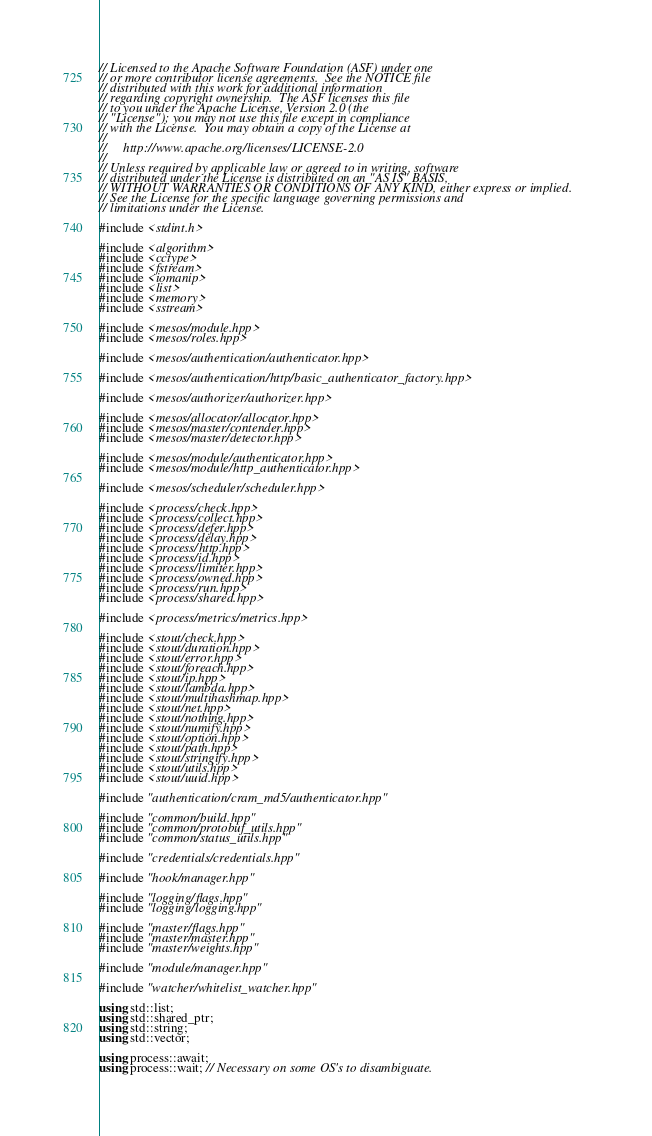Convert code to text. <code><loc_0><loc_0><loc_500><loc_500><_C++_>// Licensed to the Apache Software Foundation (ASF) under one
// or more contributor license agreements.  See the NOTICE file
// distributed with this work for additional information
// regarding copyright ownership.  The ASF licenses this file
// to you under the Apache License, Version 2.0 (the
// "License"); you may not use this file except in compliance
// with the License.  You may obtain a copy of the License at
//
//     http://www.apache.org/licenses/LICENSE-2.0
//
// Unless required by applicable law or agreed to in writing, software
// distributed under the License is distributed on an "AS IS" BASIS,
// WITHOUT WARRANTIES OR CONDITIONS OF ANY KIND, either express or implied.
// See the License for the specific language governing permissions and
// limitations under the License.

#include <stdint.h>

#include <algorithm>
#include <cctype>
#include <fstream>
#include <iomanip>
#include <list>
#include <memory>
#include <sstream>

#include <mesos/module.hpp>
#include <mesos/roles.hpp>

#include <mesos/authentication/authenticator.hpp>

#include <mesos/authentication/http/basic_authenticator_factory.hpp>

#include <mesos/authorizer/authorizer.hpp>

#include <mesos/allocator/allocator.hpp>
#include <mesos/master/contender.hpp>
#include <mesos/master/detector.hpp>

#include <mesos/module/authenticator.hpp>
#include <mesos/module/http_authenticator.hpp>

#include <mesos/scheduler/scheduler.hpp>

#include <process/check.hpp>
#include <process/collect.hpp>
#include <process/defer.hpp>
#include <process/delay.hpp>
#include <process/http.hpp>
#include <process/id.hpp>
#include <process/limiter.hpp>
#include <process/owned.hpp>
#include <process/run.hpp>
#include <process/shared.hpp>

#include <process/metrics/metrics.hpp>

#include <stout/check.hpp>
#include <stout/duration.hpp>
#include <stout/error.hpp>
#include <stout/foreach.hpp>
#include <stout/ip.hpp>
#include <stout/lambda.hpp>
#include <stout/multihashmap.hpp>
#include <stout/net.hpp>
#include <stout/nothing.hpp>
#include <stout/numify.hpp>
#include <stout/option.hpp>
#include <stout/path.hpp>
#include <stout/stringify.hpp>
#include <stout/utils.hpp>
#include <stout/uuid.hpp>

#include "authentication/cram_md5/authenticator.hpp"

#include "common/build.hpp"
#include "common/protobuf_utils.hpp"
#include "common/status_utils.hpp"

#include "credentials/credentials.hpp"

#include "hook/manager.hpp"

#include "logging/flags.hpp"
#include "logging/logging.hpp"

#include "master/flags.hpp"
#include "master/master.hpp"
#include "master/weights.hpp"

#include "module/manager.hpp"

#include "watcher/whitelist_watcher.hpp"

using std::list;
using std::shared_ptr;
using std::string;
using std::vector;

using process::await;
using process::wait; // Necessary on some OS's to disambiguate.</code> 